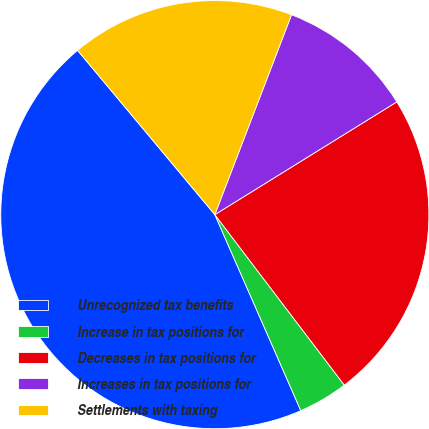Convert chart. <chart><loc_0><loc_0><loc_500><loc_500><pie_chart><fcel>Unrecognized tax benefits<fcel>Increase in tax positions for<fcel>Decreases in tax positions for<fcel>Increases in tax positions for<fcel>Settlements with taxing<nl><fcel>45.5%<fcel>3.76%<fcel>23.49%<fcel>10.34%<fcel>16.91%<nl></chart> 